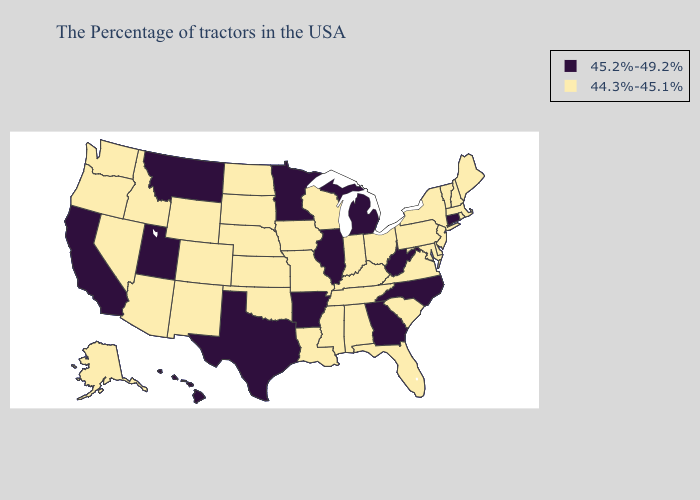Does Indiana have a higher value than Oregon?
Short answer required. No. Name the states that have a value in the range 45.2%-49.2%?
Short answer required. Connecticut, North Carolina, West Virginia, Georgia, Michigan, Illinois, Arkansas, Minnesota, Texas, Utah, Montana, California, Hawaii. Does New Jersey have the lowest value in the Northeast?
Concise answer only. Yes. What is the highest value in the USA?
Write a very short answer. 45.2%-49.2%. Name the states that have a value in the range 45.2%-49.2%?
Answer briefly. Connecticut, North Carolina, West Virginia, Georgia, Michigan, Illinois, Arkansas, Minnesota, Texas, Utah, Montana, California, Hawaii. Among the states that border Iowa , does Illinois have the highest value?
Short answer required. Yes. Name the states that have a value in the range 44.3%-45.1%?
Concise answer only. Maine, Massachusetts, Rhode Island, New Hampshire, Vermont, New York, New Jersey, Delaware, Maryland, Pennsylvania, Virginia, South Carolina, Ohio, Florida, Kentucky, Indiana, Alabama, Tennessee, Wisconsin, Mississippi, Louisiana, Missouri, Iowa, Kansas, Nebraska, Oklahoma, South Dakota, North Dakota, Wyoming, Colorado, New Mexico, Arizona, Idaho, Nevada, Washington, Oregon, Alaska. Name the states that have a value in the range 45.2%-49.2%?
Answer briefly. Connecticut, North Carolina, West Virginia, Georgia, Michigan, Illinois, Arkansas, Minnesota, Texas, Utah, Montana, California, Hawaii. What is the value of Alabama?
Short answer required. 44.3%-45.1%. Which states hav the highest value in the MidWest?
Keep it brief. Michigan, Illinois, Minnesota. Does Rhode Island have the highest value in the USA?
Be succinct. No. Name the states that have a value in the range 44.3%-45.1%?
Be succinct. Maine, Massachusetts, Rhode Island, New Hampshire, Vermont, New York, New Jersey, Delaware, Maryland, Pennsylvania, Virginia, South Carolina, Ohio, Florida, Kentucky, Indiana, Alabama, Tennessee, Wisconsin, Mississippi, Louisiana, Missouri, Iowa, Kansas, Nebraska, Oklahoma, South Dakota, North Dakota, Wyoming, Colorado, New Mexico, Arizona, Idaho, Nevada, Washington, Oregon, Alaska. How many symbols are there in the legend?
Give a very brief answer. 2. What is the value of Connecticut?
Be succinct. 45.2%-49.2%. 